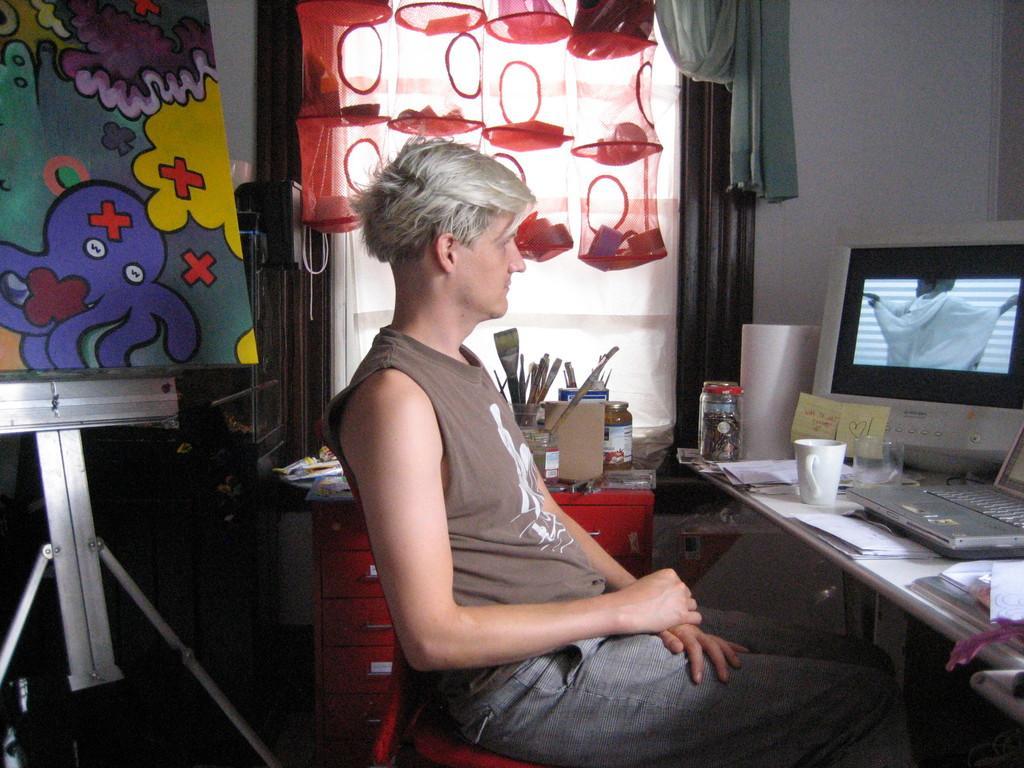Please provide a concise description of this image. In this picture, we see a man is sitting on the chair. In front of him, we see a table on which laptop, books, papers, monitor, cup, glass, charts and come other objects are placed. Beside him, we see a red drawer on which glass bottles and some other things are placed. On the left side, we see a stand and a board in different colors. In the background, we see net bags in red color. Behind that, we see a window and a curtain in green color. In the right top, we see a wall in white color. 